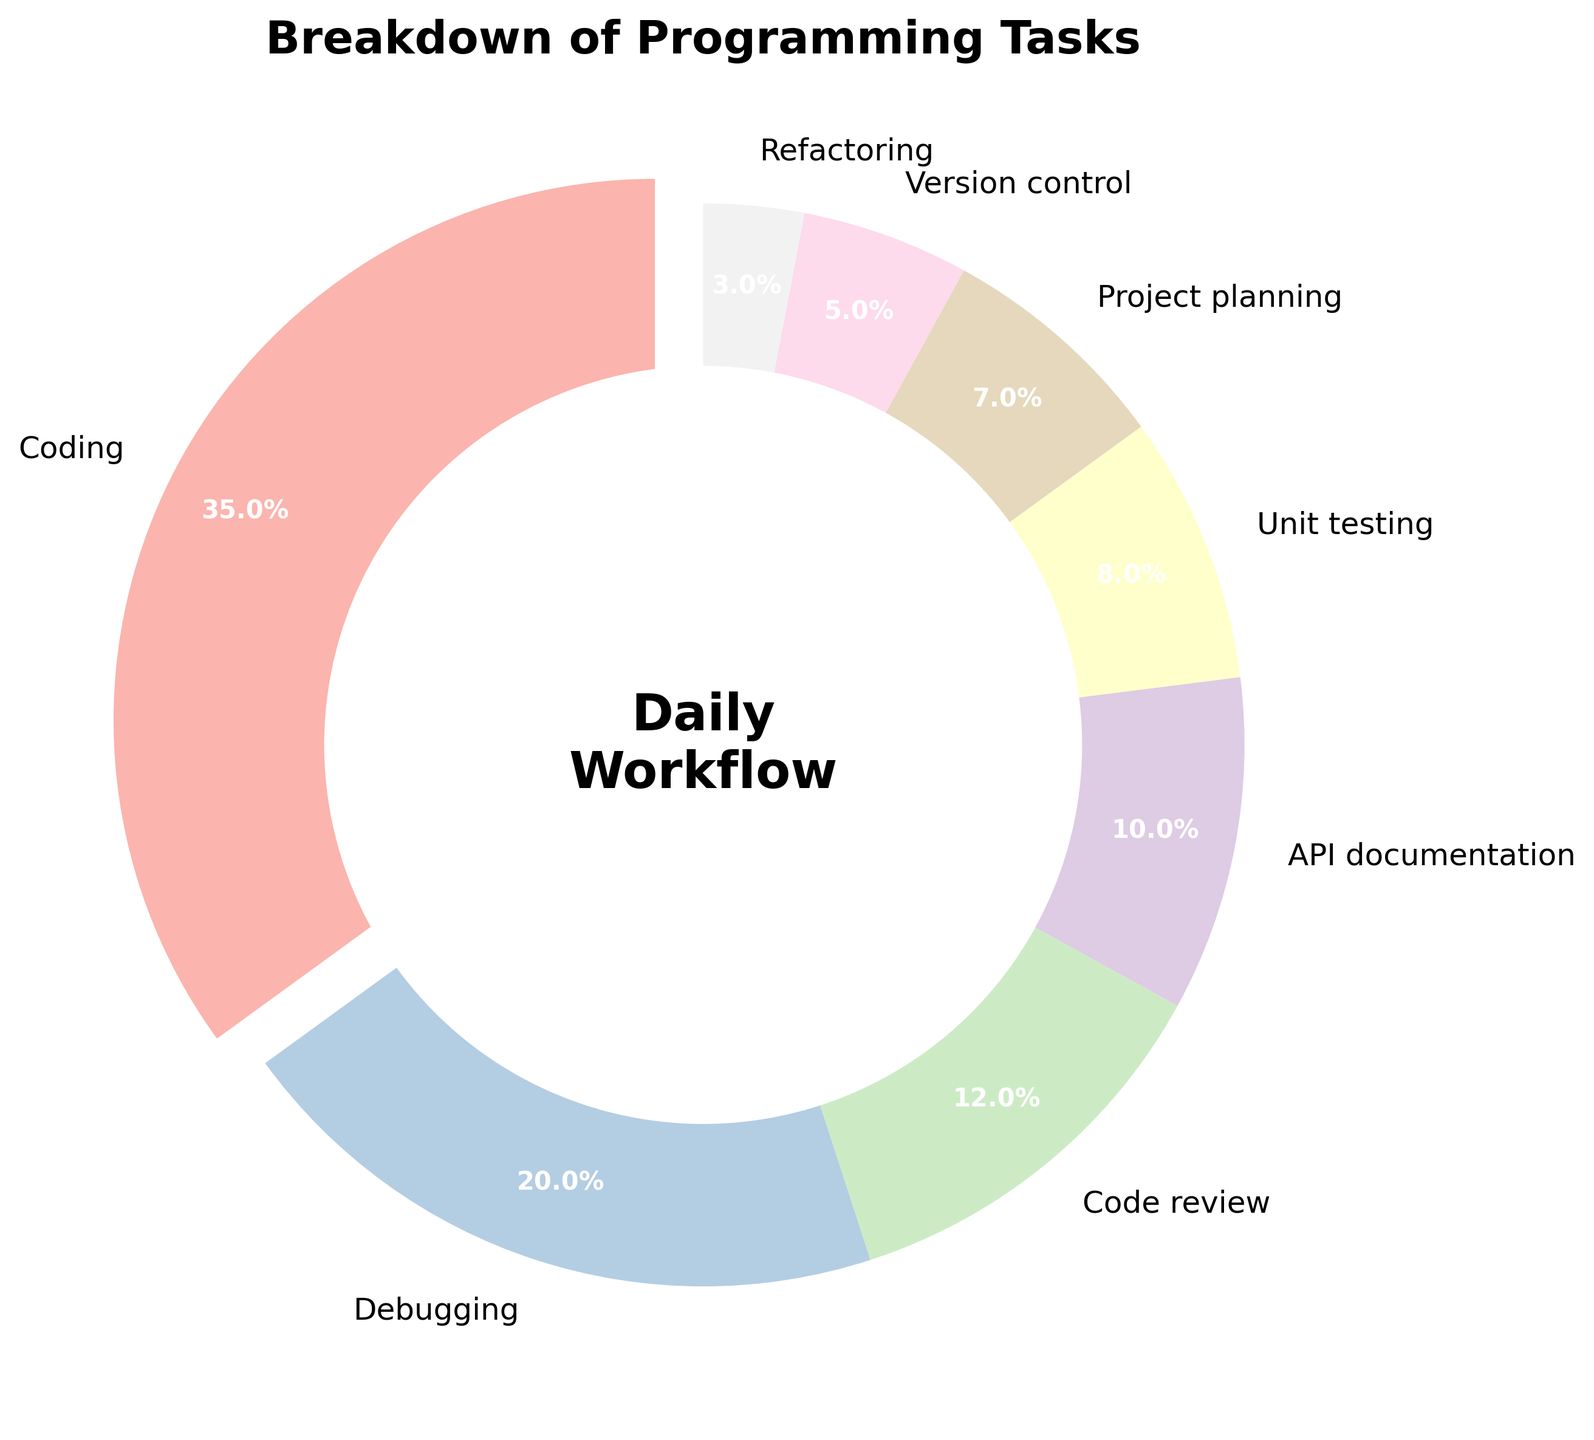What's the total percentage of time spent on tasks other than coding and debugging? First, identify the percentages of coding and debugging: 35% and 20%, respectively. Sum these to get 55%. Subtract this from 100% to find the total of the other tasks: 100% - 55% = 45%.
Answer: 45% Which task takes the most time? Observe the segment with the largest percentage. The task "Coding" has the largest segment at 35%.
Answer: Coding How much more time is spent on code review compared to project planning? Identify the percentages for code review and project planning: 12% and 7%, respectively. Subtract the smaller percentage from the larger one: 12% - 7% = 5%.
Answer: 5% What is the combined percentage of time spent on API documentation and unit testing? Identify the percentages for API documentation and unit testing: 10% and 8%, respectively. Sum these percentages: 10% + 8% = 18%.
Answer: 18% Is more time spent on version control or refactoring? Compare the percentages for version control and refactoring: 5% and 3%, respectively. The larger percentage is 5% for version control.
Answer: Version control What percentage of time is spent on coding and debugging combined? Identify the percentages for coding and debugging: 35% and 20%, respectively. Sum these percentages: 35% + 20% = 55%.
Answer: 55% Which task has the smallest segment in the pie chart? Observe the smallest segment in the chart. The task "Refactoring" has the smallest percentage at 3%.
Answer: Refactoring How does the time spent on unit testing compare to the time spent on project planning? Identify the percentages for unit testing and project planning: 8% and 7%, respectively. Unit testing has a 1% higher percentage than project planning.
Answer: Unit testing What is the difference in time spent between the task with the maximum percentage and the task with the minimum percentage? Identify the percentages for the maximum (coding at 35%) and the minimum (refactoring at 3%). Subtract the smaller percentage from the larger one: 35% - 3% = 32%.
Answer: 32% What's the average percentage of time spent on debugging, code review, and API documentation? Identify the percentages: debugging (20%), code review (12%), and API documentation (10%). Sum these: 20% + 12% + 10% = 42%. Divide by the number of tasks, which is 3: 42% / 3 ≈ 14%.
Answer: 14% 